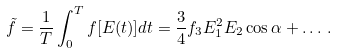Convert formula to latex. <formula><loc_0><loc_0><loc_500><loc_500>\tilde { f } = \frac { 1 } { T } \int _ { 0 } ^ { T } f [ E ( t ) ] d t = \frac { 3 } { 4 } f _ { 3 } E _ { 1 } ^ { 2 } E _ { 2 } \cos \alpha + \dots \, .</formula> 